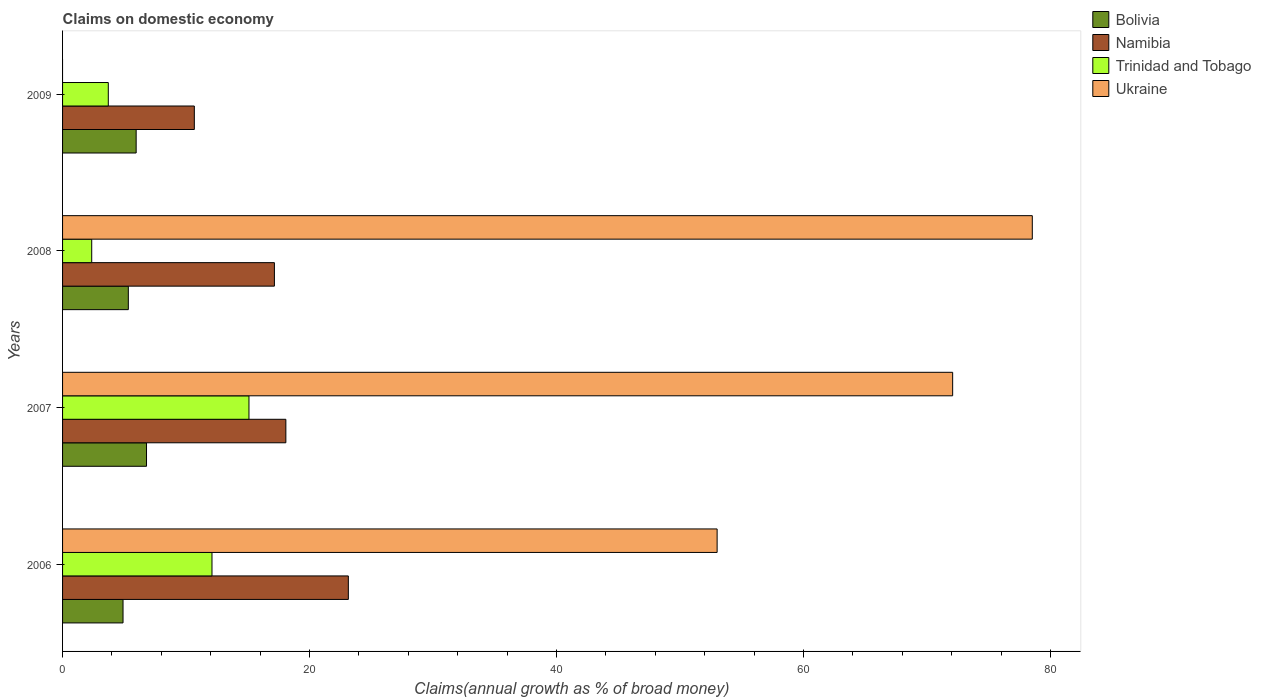Are the number of bars per tick equal to the number of legend labels?
Offer a terse response. No. How many bars are there on the 2nd tick from the top?
Make the answer very short. 4. What is the label of the 4th group of bars from the top?
Ensure brevity in your answer.  2006. What is the percentage of broad money claimed on domestic economy in Bolivia in 2008?
Your answer should be very brief. 5.33. Across all years, what is the maximum percentage of broad money claimed on domestic economy in Trinidad and Tobago?
Make the answer very short. 15.09. Across all years, what is the minimum percentage of broad money claimed on domestic economy in Bolivia?
Give a very brief answer. 4.9. In which year was the percentage of broad money claimed on domestic economy in Namibia maximum?
Ensure brevity in your answer.  2006. What is the total percentage of broad money claimed on domestic economy in Trinidad and Tobago in the graph?
Offer a terse response. 33.26. What is the difference between the percentage of broad money claimed on domestic economy in Ukraine in 2006 and that in 2008?
Your response must be concise. -25.52. What is the difference between the percentage of broad money claimed on domestic economy in Namibia in 2009 and the percentage of broad money claimed on domestic economy in Bolivia in 2007?
Ensure brevity in your answer.  3.87. What is the average percentage of broad money claimed on domestic economy in Ukraine per year?
Make the answer very short. 50.9. In the year 2006, what is the difference between the percentage of broad money claimed on domestic economy in Trinidad and Tobago and percentage of broad money claimed on domestic economy in Ukraine?
Ensure brevity in your answer.  -40.91. What is the ratio of the percentage of broad money claimed on domestic economy in Trinidad and Tobago in 2006 to that in 2009?
Offer a terse response. 3.27. Is the percentage of broad money claimed on domestic economy in Ukraine in 2006 less than that in 2008?
Offer a terse response. Yes. What is the difference between the highest and the second highest percentage of broad money claimed on domestic economy in Trinidad and Tobago?
Ensure brevity in your answer.  3. What is the difference between the highest and the lowest percentage of broad money claimed on domestic economy in Bolivia?
Give a very brief answer. 1.9. Are all the bars in the graph horizontal?
Give a very brief answer. Yes. How many years are there in the graph?
Keep it short and to the point. 4. What is the difference between two consecutive major ticks on the X-axis?
Ensure brevity in your answer.  20. Does the graph contain grids?
Make the answer very short. No. How many legend labels are there?
Offer a terse response. 4. How are the legend labels stacked?
Ensure brevity in your answer.  Vertical. What is the title of the graph?
Give a very brief answer. Claims on domestic economy. Does "Burkina Faso" appear as one of the legend labels in the graph?
Your answer should be very brief. No. What is the label or title of the X-axis?
Provide a succinct answer. Claims(annual growth as % of broad money). What is the label or title of the Y-axis?
Make the answer very short. Years. What is the Claims(annual growth as % of broad money) in Bolivia in 2006?
Your answer should be compact. 4.9. What is the Claims(annual growth as % of broad money) in Namibia in 2006?
Keep it short and to the point. 23.14. What is the Claims(annual growth as % of broad money) of Trinidad and Tobago in 2006?
Keep it short and to the point. 12.1. What is the Claims(annual growth as % of broad money) of Ukraine in 2006?
Make the answer very short. 53. What is the Claims(annual growth as % of broad money) in Bolivia in 2007?
Offer a very short reply. 6.8. What is the Claims(annual growth as % of broad money) of Namibia in 2007?
Keep it short and to the point. 18.08. What is the Claims(annual growth as % of broad money) of Trinidad and Tobago in 2007?
Give a very brief answer. 15.09. What is the Claims(annual growth as % of broad money) of Ukraine in 2007?
Offer a terse response. 72.08. What is the Claims(annual growth as % of broad money) in Bolivia in 2008?
Your answer should be compact. 5.33. What is the Claims(annual growth as % of broad money) of Namibia in 2008?
Make the answer very short. 17.15. What is the Claims(annual growth as % of broad money) in Trinidad and Tobago in 2008?
Make the answer very short. 2.36. What is the Claims(annual growth as % of broad money) in Ukraine in 2008?
Provide a short and direct response. 78.53. What is the Claims(annual growth as % of broad money) in Bolivia in 2009?
Ensure brevity in your answer.  5.96. What is the Claims(annual growth as % of broad money) of Namibia in 2009?
Your answer should be very brief. 10.67. What is the Claims(annual growth as % of broad money) in Trinidad and Tobago in 2009?
Provide a short and direct response. 3.7. What is the Claims(annual growth as % of broad money) of Ukraine in 2009?
Keep it short and to the point. 0. Across all years, what is the maximum Claims(annual growth as % of broad money) in Bolivia?
Your answer should be compact. 6.8. Across all years, what is the maximum Claims(annual growth as % of broad money) of Namibia?
Give a very brief answer. 23.14. Across all years, what is the maximum Claims(annual growth as % of broad money) of Trinidad and Tobago?
Offer a terse response. 15.09. Across all years, what is the maximum Claims(annual growth as % of broad money) of Ukraine?
Keep it short and to the point. 78.53. Across all years, what is the minimum Claims(annual growth as % of broad money) of Bolivia?
Give a very brief answer. 4.9. Across all years, what is the minimum Claims(annual growth as % of broad money) in Namibia?
Your response must be concise. 10.67. Across all years, what is the minimum Claims(annual growth as % of broad money) in Trinidad and Tobago?
Provide a short and direct response. 2.36. Across all years, what is the minimum Claims(annual growth as % of broad money) of Ukraine?
Make the answer very short. 0. What is the total Claims(annual growth as % of broad money) of Bolivia in the graph?
Your response must be concise. 22.98. What is the total Claims(annual growth as % of broad money) of Namibia in the graph?
Your answer should be compact. 69.05. What is the total Claims(annual growth as % of broad money) in Trinidad and Tobago in the graph?
Your answer should be compact. 33.26. What is the total Claims(annual growth as % of broad money) in Ukraine in the graph?
Offer a terse response. 203.61. What is the difference between the Claims(annual growth as % of broad money) in Bolivia in 2006 and that in 2007?
Offer a terse response. -1.9. What is the difference between the Claims(annual growth as % of broad money) in Namibia in 2006 and that in 2007?
Make the answer very short. 5.06. What is the difference between the Claims(annual growth as % of broad money) of Trinidad and Tobago in 2006 and that in 2007?
Your answer should be compact. -3. What is the difference between the Claims(annual growth as % of broad money) of Ukraine in 2006 and that in 2007?
Your response must be concise. -19.07. What is the difference between the Claims(annual growth as % of broad money) in Bolivia in 2006 and that in 2008?
Provide a short and direct response. -0.43. What is the difference between the Claims(annual growth as % of broad money) of Namibia in 2006 and that in 2008?
Your response must be concise. 5.99. What is the difference between the Claims(annual growth as % of broad money) of Trinidad and Tobago in 2006 and that in 2008?
Keep it short and to the point. 9.74. What is the difference between the Claims(annual growth as % of broad money) in Ukraine in 2006 and that in 2008?
Make the answer very short. -25.52. What is the difference between the Claims(annual growth as % of broad money) of Bolivia in 2006 and that in 2009?
Keep it short and to the point. -1.06. What is the difference between the Claims(annual growth as % of broad money) in Namibia in 2006 and that in 2009?
Ensure brevity in your answer.  12.47. What is the difference between the Claims(annual growth as % of broad money) in Trinidad and Tobago in 2006 and that in 2009?
Offer a very short reply. 8.4. What is the difference between the Claims(annual growth as % of broad money) in Bolivia in 2007 and that in 2008?
Offer a terse response. 1.47. What is the difference between the Claims(annual growth as % of broad money) of Namibia in 2007 and that in 2008?
Your answer should be compact. 0.93. What is the difference between the Claims(annual growth as % of broad money) of Trinidad and Tobago in 2007 and that in 2008?
Your answer should be very brief. 12.73. What is the difference between the Claims(annual growth as % of broad money) in Ukraine in 2007 and that in 2008?
Keep it short and to the point. -6.45. What is the difference between the Claims(annual growth as % of broad money) of Bolivia in 2007 and that in 2009?
Offer a very short reply. 0.84. What is the difference between the Claims(annual growth as % of broad money) of Namibia in 2007 and that in 2009?
Give a very brief answer. 7.41. What is the difference between the Claims(annual growth as % of broad money) of Trinidad and Tobago in 2007 and that in 2009?
Your answer should be compact. 11.39. What is the difference between the Claims(annual growth as % of broad money) in Bolivia in 2008 and that in 2009?
Your answer should be compact. -0.63. What is the difference between the Claims(annual growth as % of broad money) of Namibia in 2008 and that in 2009?
Your answer should be very brief. 6.49. What is the difference between the Claims(annual growth as % of broad money) in Trinidad and Tobago in 2008 and that in 2009?
Your answer should be compact. -1.34. What is the difference between the Claims(annual growth as % of broad money) in Bolivia in 2006 and the Claims(annual growth as % of broad money) in Namibia in 2007?
Your response must be concise. -13.19. What is the difference between the Claims(annual growth as % of broad money) of Bolivia in 2006 and the Claims(annual growth as % of broad money) of Trinidad and Tobago in 2007?
Your answer should be compact. -10.2. What is the difference between the Claims(annual growth as % of broad money) of Bolivia in 2006 and the Claims(annual growth as % of broad money) of Ukraine in 2007?
Your answer should be very brief. -67.18. What is the difference between the Claims(annual growth as % of broad money) in Namibia in 2006 and the Claims(annual growth as % of broad money) in Trinidad and Tobago in 2007?
Offer a very short reply. 8.05. What is the difference between the Claims(annual growth as % of broad money) in Namibia in 2006 and the Claims(annual growth as % of broad money) in Ukraine in 2007?
Offer a terse response. -48.94. What is the difference between the Claims(annual growth as % of broad money) in Trinidad and Tobago in 2006 and the Claims(annual growth as % of broad money) in Ukraine in 2007?
Keep it short and to the point. -59.98. What is the difference between the Claims(annual growth as % of broad money) in Bolivia in 2006 and the Claims(annual growth as % of broad money) in Namibia in 2008?
Your answer should be very brief. -12.26. What is the difference between the Claims(annual growth as % of broad money) in Bolivia in 2006 and the Claims(annual growth as % of broad money) in Trinidad and Tobago in 2008?
Make the answer very short. 2.54. What is the difference between the Claims(annual growth as % of broad money) in Bolivia in 2006 and the Claims(annual growth as % of broad money) in Ukraine in 2008?
Your answer should be very brief. -73.63. What is the difference between the Claims(annual growth as % of broad money) in Namibia in 2006 and the Claims(annual growth as % of broad money) in Trinidad and Tobago in 2008?
Offer a very short reply. 20.78. What is the difference between the Claims(annual growth as % of broad money) in Namibia in 2006 and the Claims(annual growth as % of broad money) in Ukraine in 2008?
Give a very brief answer. -55.38. What is the difference between the Claims(annual growth as % of broad money) in Trinidad and Tobago in 2006 and the Claims(annual growth as % of broad money) in Ukraine in 2008?
Give a very brief answer. -66.43. What is the difference between the Claims(annual growth as % of broad money) of Bolivia in 2006 and the Claims(annual growth as % of broad money) of Namibia in 2009?
Keep it short and to the point. -5.77. What is the difference between the Claims(annual growth as % of broad money) in Bolivia in 2006 and the Claims(annual growth as % of broad money) in Trinidad and Tobago in 2009?
Provide a short and direct response. 1.19. What is the difference between the Claims(annual growth as % of broad money) in Namibia in 2006 and the Claims(annual growth as % of broad money) in Trinidad and Tobago in 2009?
Provide a short and direct response. 19.44. What is the difference between the Claims(annual growth as % of broad money) in Bolivia in 2007 and the Claims(annual growth as % of broad money) in Namibia in 2008?
Ensure brevity in your answer.  -10.36. What is the difference between the Claims(annual growth as % of broad money) in Bolivia in 2007 and the Claims(annual growth as % of broad money) in Trinidad and Tobago in 2008?
Offer a terse response. 4.44. What is the difference between the Claims(annual growth as % of broad money) in Bolivia in 2007 and the Claims(annual growth as % of broad money) in Ukraine in 2008?
Keep it short and to the point. -71.73. What is the difference between the Claims(annual growth as % of broad money) in Namibia in 2007 and the Claims(annual growth as % of broad money) in Trinidad and Tobago in 2008?
Your answer should be compact. 15.72. What is the difference between the Claims(annual growth as % of broad money) of Namibia in 2007 and the Claims(annual growth as % of broad money) of Ukraine in 2008?
Make the answer very short. -60.44. What is the difference between the Claims(annual growth as % of broad money) in Trinidad and Tobago in 2007 and the Claims(annual growth as % of broad money) in Ukraine in 2008?
Give a very brief answer. -63.43. What is the difference between the Claims(annual growth as % of broad money) of Bolivia in 2007 and the Claims(annual growth as % of broad money) of Namibia in 2009?
Offer a very short reply. -3.87. What is the difference between the Claims(annual growth as % of broad money) in Bolivia in 2007 and the Claims(annual growth as % of broad money) in Trinidad and Tobago in 2009?
Offer a very short reply. 3.1. What is the difference between the Claims(annual growth as % of broad money) in Namibia in 2007 and the Claims(annual growth as % of broad money) in Trinidad and Tobago in 2009?
Your answer should be compact. 14.38. What is the difference between the Claims(annual growth as % of broad money) of Bolivia in 2008 and the Claims(annual growth as % of broad money) of Namibia in 2009?
Your answer should be very brief. -5.34. What is the difference between the Claims(annual growth as % of broad money) in Bolivia in 2008 and the Claims(annual growth as % of broad money) in Trinidad and Tobago in 2009?
Ensure brevity in your answer.  1.62. What is the difference between the Claims(annual growth as % of broad money) of Namibia in 2008 and the Claims(annual growth as % of broad money) of Trinidad and Tobago in 2009?
Make the answer very short. 13.45. What is the average Claims(annual growth as % of broad money) in Bolivia per year?
Ensure brevity in your answer.  5.74. What is the average Claims(annual growth as % of broad money) of Namibia per year?
Your response must be concise. 17.26. What is the average Claims(annual growth as % of broad money) of Trinidad and Tobago per year?
Provide a short and direct response. 8.31. What is the average Claims(annual growth as % of broad money) of Ukraine per year?
Your answer should be compact. 50.9. In the year 2006, what is the difference between the Claims(annual growth as % of broad money) of Bolivia and Claims(annual growth as % of broad money) of Namibia?
Provide a succinct answer. -18.25. In the year 2006, what is the difference between the Claims(annual growth as % of broad money) in Bolivia and Claims(annual growth as % of broad money) in Trinidad and Tobago?
Offer a very short reply. -7.2. In the year 2006, what is the difference between the Claims(annual growth as % of broad money) in Bolivia and Claims(annual growth as % of broad money) in Ukraine?
Give a very brief answer. -48.11. In the year 2006, what is the difference between the Claims(annual growth as % of broad money) in Namibia and Claims(annual growth as % of broad money) in Trinidad and Tobago?
Make the answer very short. 11.04. In the year 2006, what is the difference between the Claims(annual growth as % of broad money) in Namibia and Claims(annual growth as % of broad money) in Ukraine?
Offer a terse response. -29.86. In the year 2006, what is the difference between the Claims(annual growth as % of broad money) of Trinidad and Tobago and Claims(annual growth as % of broad money) of Ukraine?
Offer a very short reply. -40.91. In the year 2007, what is the difference between the Claims(annual growth as % of broad money) in Bolivia and Claims(annual growth as % of broad money) in Namibia?
Keep it short and to the point. -11.28. In the year 2007, what is the difference between the Claims(annual growth as % of broad money) of Bolivia and Claims(annual growth as % of broad money) of Trinidad and Tobago?
Ensure brevity in your answer.  -8.3. In the year 2007, what is the difference between the Claims(annual growth as % of broad money) in Bolivia and Claims(annual growth as % of broad money) in Ukraine?
Provide a short and direct response. -65.28. In the year 2007, what is the difference between the Claims(annual growth as % of broad money) in Namibia and Claims(annual growth as % of broad money) in Trinidad and Tobago?
Ensure brevity in your answer.  2.99. In the year 2007, what is the difference between the Claims(annual growth as % of broad money) in Namibia and Claims(annual growth as % of broad money) in Ukraine?
Give a very brief answer. -54. In the year 2007, what is the difference between the Claims(annual growth as % of broad money) in Trinidad and Tobago and Claims(annual growth as % of broad money) in Ukraine?
Provide a short and direct response. -56.98. In the year 2008, what is the difference between the Claims(annual growth as % of broad money) of Bolivia and Claims(annual growth as % of broad money) of Namibia?
Offer a terse response. -11.83. In the year 2008, what is the difference between the Claims(annual growth as % of broad money) of Bolivia and Claims(annual growth as % of broad money) of Trinidad and Tobago?
Offer a very short reply. 2.96. In the year 2008, what is the difference between the Claims(annual growth as % of broad money) in Bolivia and Claims(annual growth as % of broad money) in Ukraine?
Your answer should be very brief. -73.2. In the year 2008, what is the difference between the Claims(annual growth as % of broad money) in Namibia and Claims(annual growth as % of broad money) in Trinidad and Tobago?
Your response must be concise. 14.79. In the year 2008, what is the difference between the Claims(annual growth as % of broad money) in Namibia and Claims(annual growth as % of broad money) in Ukraine?
Your answer should be compact. -61.37. In the year 2008, what is the difference between the Claims(annual growth as % of broad money) of Trinidad and Tobago and Claims(annual growth as % of broad money) of Ukraine?
Give a very brief answer. -76.17. In the year 2009, what is the difference between the Claims(annual growth as % of broad money) of Bolivia and Claims(annual growth as % of broad money) of Namibia?
Your response must be concise. -4.71. In the year 2009, what is the difference between the Claims(annual growth as % of broad money) in Bolivia and Claims(annual growth as % of broad money) in Trinidad and Tobago?
Make the answer very short. 2.26. In the year 2009, what is the difference between the Claims(annual growth as % of broad money) of Namibia and Claims(annual growth as % of broad money) of Trinidad and Tobago?
Offer a terse response. 6.97. What is the ratio of the Claims(annual growth as % of broad money) in Bolivia in 2006 to that in 2007?
Keep it short and to the point. 0.72. What is the ratio of the Claims(annual growth as % of broad money) in Namibia in 2006 to that in 2007?
Your answer should be compact. 1.28. What is the ratio of the Claims(annual growth as % of broad money) in Trinidad and Tobago in 2006 to that in 2007?
Offer a very short reply. 0.8. What is the ratio of the Claims(annual growth as % of broad money) of Ukraine in 2006 to that in 2007?
Your response must be concise. 0.74. What is the ratio of the Claims(annual growth as % of broad money) in Bolivia in 2006 to that in 2008?
Offer a terse response. 0.92. What is the ratio of the Claims(annual growth as % of broad money) of Namibia in 2006 to that in 2008?
Make the answer very short. 1.35. What is the ratio of the Claims(annual growth as % of broad money) in Trinidad and Tobago in 2006 to that in 2008?
Keep it short and to the point. 5.13. What is the ratio of the Claims(annual growth as % of broad money) in Ukraine in 2006 to that in 2008?
Ensure brevity in your answer.  0.68. What is the ratio of the Claims(annual growth as % of broad money) of Bolivia in 2006 to that in 2009?
Your answer should be compact. 0.82. What is the ratio of the Claims(annual growth as % of broad money) of Namibia in 2006 to that in 2009?
Make the answer very short. 2.17. What is the ratio of the Claims(annual growth as % of broad money) in Trinidad and Tobago in 2006 to that in 2009?
Give a very brief answer. 3.27. What is the ratio of the Claims(annual growth as % of broad money) of Bolivia in 2007 to that in 2008?
Provide a short and direct response. 1.28. What is the ratio of the Claims(annual growth as % of broad money) in Namibia in 2007 to that in 2008?
Make the answer very short. 1.05. What is the ratio of the Claims(annual growth as % of broad money) of Trinidad and Tobago in 2007 to that in 2008?
Offer a very short reply. 6.4. What is the ratio of the Claims(annual growth as % of broad money) in Ukraine in 2007 to that in 2008?
Keep it short and to the point. 0.92. What is the ratio of the Claims(annual growth as % of broad money) of Bolivia in 2007 to that in 2009?
Your response must be concise. 1.14. What is the ratio of the Claims(annual growth as % of broad money) of Namibia in 2007 to that in 2009?
Ensure brevity in your answer.  1.69. What is the ratio of the Claims(annual growth as % of broad money) in Trinidad and Tobago in 2007 to that in 2009?
Offer a very short reply. 4.08. What is the ratio of the Claims(annual growth as % of broad money) in Bolivia in 2008 to that in 2009?
Ensure brevity in your answer.  0.89. What is the ratio of the Claims(annual growth as % of broad money) in Namibia in 2008 to that in 2009?
Your response must be concise. 1.61. What is the ratio of the Claims(annual growth as % of broad money) in Trinidad and Tobago in 2008 to that in 2009?
Your answer should be compact. 0.64. What is the difference between the highest and the second highest Claims(annual growth as % of broad money) in Bolivia?
Make the answer very short. 0.84. What is the difference between the highest and the second highest Claims(annual growth as % of broad money) in Namibia?
Offer a very short reply. 5.06. What is the difference between the highest and the second highest Claims(annual growth as % of broad money) of Trinidad and Tobago?
Ensure brevity in your answer.  3. What is the difference between the highest and the second highest Claims(annual growth as % of broad money) of Ukraine?
Provide a short and direct response. 6.45. What is the difference between the highest and the lowest Claims(annual growth as % of broad money) of Bolivia?
Ensure brevity in your answer.  1.9. What is the difference between the highest and the lowest Claims(annual growth as % of broad money) of Namibia?
Provide a succinct answer. 12.47. What is the difference between the highest and the lowest Claims(annual growth as % of broad money) of Trinidad and Tobago?
Keep it short and to the point. 12.73. What is the difference between the highest and the lowest Claims(annual growth as % of broad money) of Ukraine?
Your response must be concise. 78.53. 